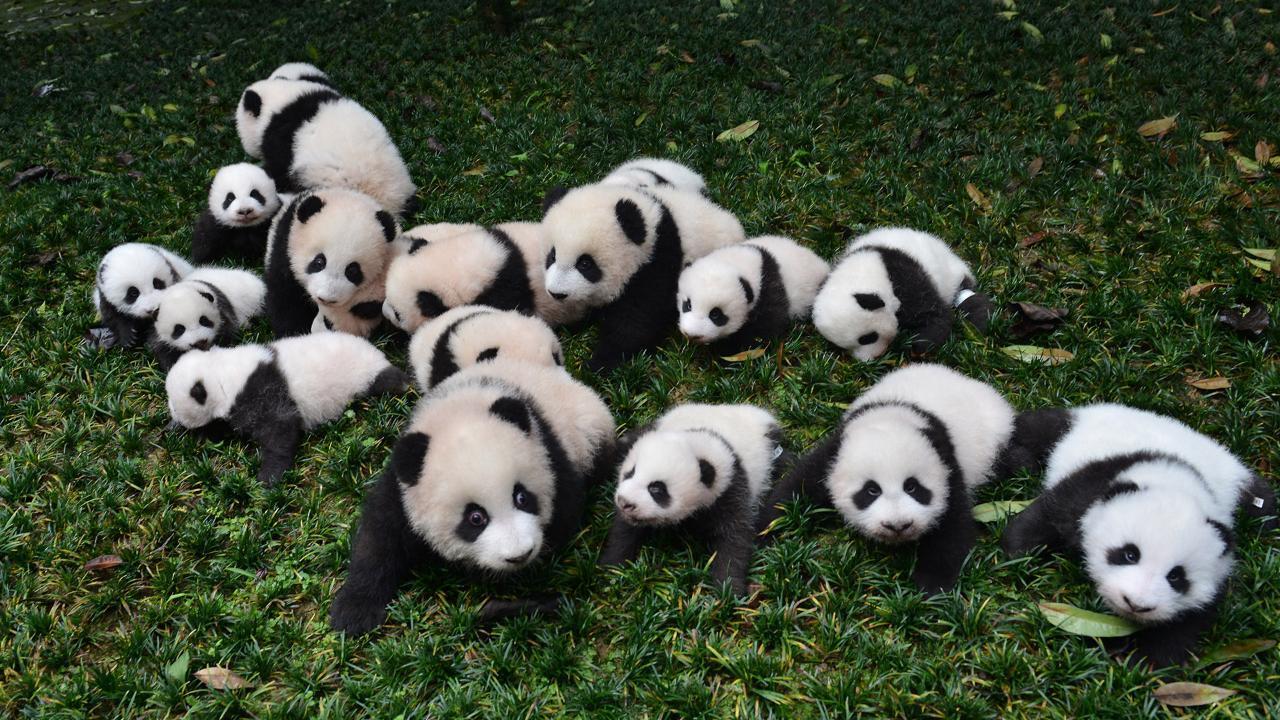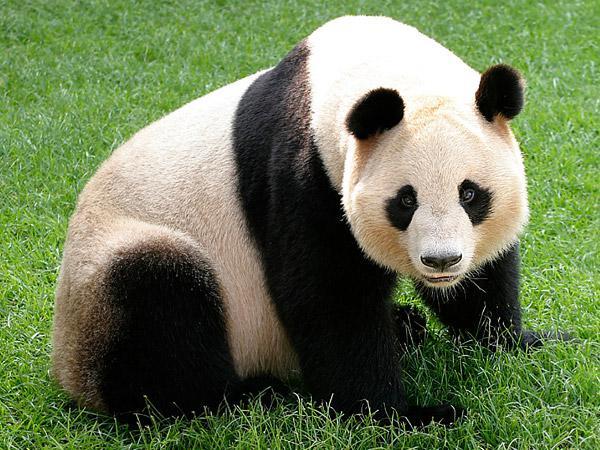The first image is the image on the left, the second image is the image on the right. Assess this claim about the two images: "There is exactly one panda with all feet on the ground in one of the images". Correct or not? Answer yes or no. Yes. The first image is the image on the left, the second image is the image on the right. Analyze the images presented: Is the assertion "The panda in the right image has paws on a branch." valid? Answer yes or no. No. 